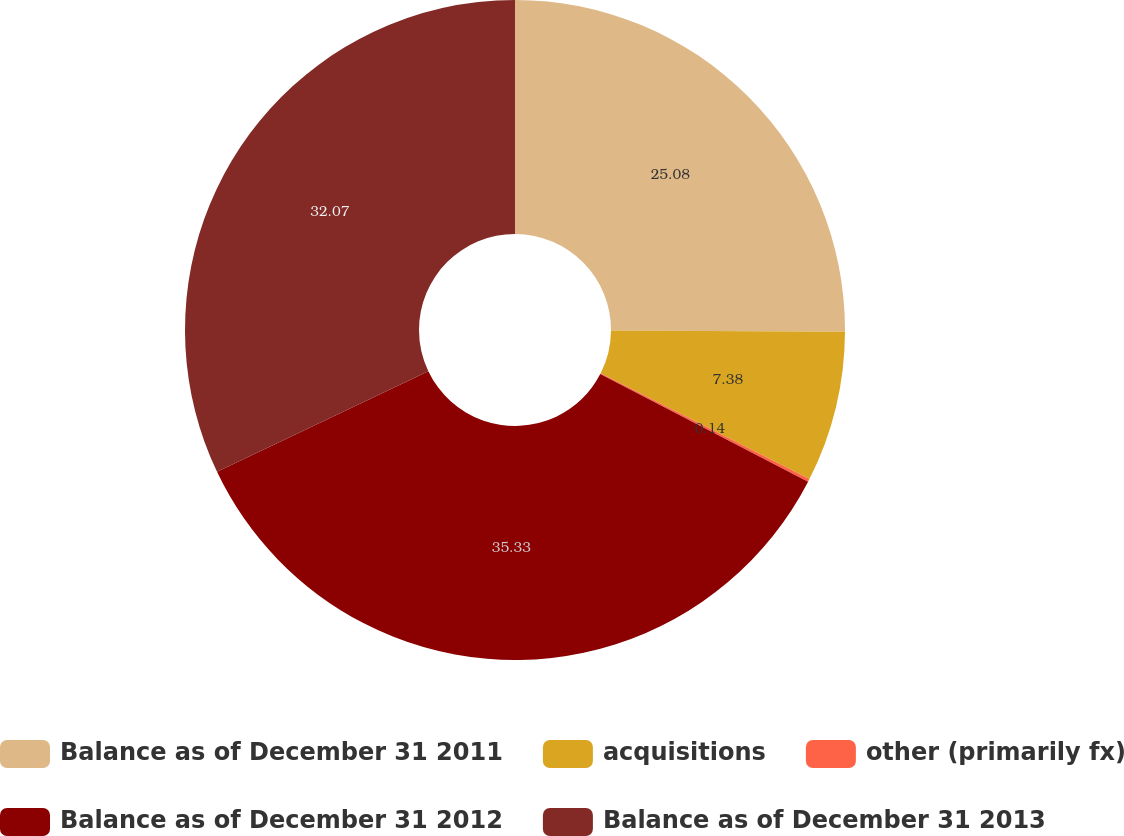<chart> <loc_0><loc_0><loc_500><loc_500><pie_chart><fcel>Balance as of December 31 2011<fcel>acquisitions<fcel>other (primarily fx)<fcel>Balance as of December 31 2012<fcel>Balance as of December 31 2013<nl><fcel>25.08%<fcel>7.38%<fcel>0.14%<fcel>35.33%<fcel>32.07%<nl></chart> 